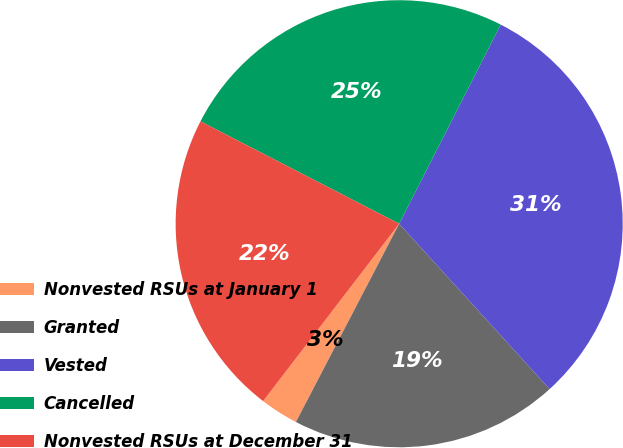<chart> <loc_0><loc_0><loc_500><loc_500><pie_chart><fcel>Nonvested RSUs at January 1<fcel>Granted<fcel>Vested<fcel>Cancelled<fcel>Nonvested RSUs at December 31<nl><fcel>2.77%<fcel>19.39%<fcel>30.75%<fcel>24.93%<fcel>22.16%<nl></chart> 